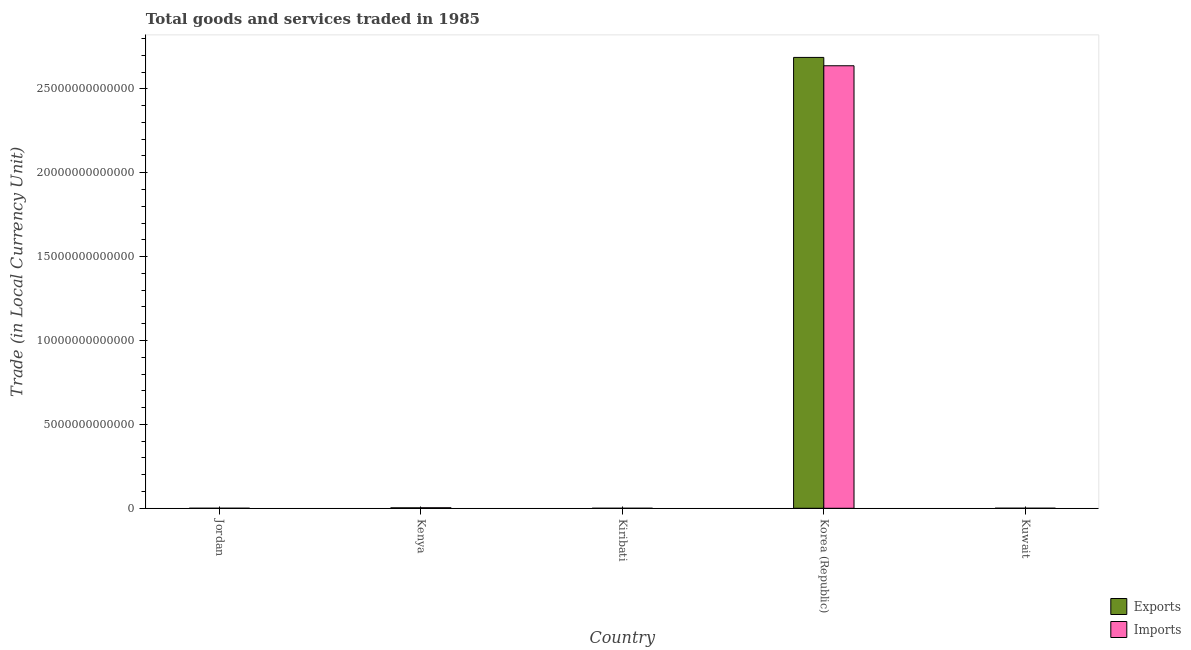How many different coloured bars are there?
Make the answer very short. 2. Are the number of bars per tick equal to the number of legend labels?
Your answer should be compact. Yes. Are the number of bars on each tick of the X-axis equal?
Give a very brief answer. Yes. How many bars are there on the 2nd tick from the left?
Your answer should be compact. 2. What is the label of the 4th group of bars from the left?
Make the answer very short. Korea (Republic). In how many cases, is the number of bars for a given country not equal to the number of legend labels?
Your answer should be compact. 0. What is the export of goods and services in Kenya?
Offer a very short reply. 2.55e+1. Across all countries, what is the maximum export of goods and services?
Ensure brevity in your answer.  2.69e+13. Across all countries, what is the minimum export of goods and services?
Your answer should be very brief. 6.44e+06. In which country was the imports of goods and services maximum?
Make the answer very short. Korea (Republic). In which country was the imports of goods and services minimum?
Your answer should be very brief. Kiribati. What is the total export of goods and services in the graph?
Make the answer very short. 2.69e+13. What is the difference between the imports of goods and services in Jordan and that in Kiribati?
Provide a succinct answer. 1.46e+09. What is the difference between the imports of goods and services in Kenya and the export of goods and services in Korea (Republic)?
Your response must be concise. -2.68e+13. What is the average export of goods and services per country?
Offer a terse response. 5.38e+12. What is the difference between the imports of goods and services and export of goods and services in Kuwait?
Your answer should be very brief. -7.05e+08. What is the ratio of the export of goods and services in Jordan to that in Kenya?
Offer a terse response. 0.03. Is the export of goods and services in Kenya less than that in Korea (Republic)?
Your answer should be very brief. Yes. Is the difference between the export of goods and services in Kenya and Korea (Republic) greater than the difference between the imports of goods and services in Kenya and Korea (Republic)?
Offer a very short reply. No. What is the difference between the highest and the second highest export of goods and services?
Offer a very short reply. 2.69e+13. What is the difference between the highest and the lowest export of goods and services?
Your answer should be very brief. 2.69e+13. Is the sum of the imports of goods and services in Jordan and Kiribati greater than the maximum export of goods and services across all countries?
Keep it short and to the point. No. What does the 2nd bar from the left in Korea (Republic) represents?
Offer a very short reply. Imports. What does the 1st bar from the right in Kuwait represents?
Your answer should be very brief. Imports. How many bars are there?
Give a very brief answer. 10. Are all the bars in the graph horizontal?
Keep it short and to the point. No. What is the difference between two consecutive major ticks on the Y-axis?
Your response must be concise. 5.00e+12. Are the values on the major ticks of Y-axis written in scientific E-notation?
Give a very brief answer. No. How are the legend labels stacked?
Provide a succinct answer. Vertical. What is the title of the graph?
Ensure brevity in your answer.  Total goods and services traded in 1985. What is the label or title of the Y-axis?
Keep it short and to the point. Trade (in Local Currency Unit). What is the Trade (in Local Currency Unit) in Exports in Jordan?
Make the answer very short. 7.82e+08. What is the Trade (in Local Currency Unit) of Imports in Jordan?
Provide a short and direct response. 1.50e+09. What is the Trade (in Local Currency Unit) of Exports in Kenya?
Make the answer very short. 2.55e+1. What is the Trade (in Local Currency Unit) of Imports in Kenya?
Your response must be concise. 3.04e+1. What is the Trade (in Local Currency Unit) of Exports in Kiribati?
Your response must be concise. 6.44e+06. What is the Trade (in Local Currency Unit) in Imports in Kiribati?
Offer a terse response. 3.84e+07. What is the Trade (in Local Currency Unit) in Exports in Korea (Republic)?
Make the answer very short. 2.69e+13. What is the Trade (in Local Currency Unit) of Imports in Korea (Republic)?
Give a very brief answer. 2.64e+13. What is the Trade (in Local Currency Unit) of Exports in Kuwait?
Your answer should be very brief. 3.46e+09. What is the Trade (in Local Currency Unit) of Imports in Kuwait?
Your response must be concise. 2.76e+09. Across all countries, what is the maximum Trade (in Local Currency Unit) of Exports?
Your response must be concise. 2.69e+13. Across all countries, what is the maximum Trade (in Local Currency Unit) of Imports?
Your response must be concise. 2.64e+13. Across all countries, what is the minimum Trade (in Local Currency Unit) of Exports?
Keep it short and to the point. 6.44e+06. Across all countries, what is the minimum Trade (in Local Currency Unit) of Imports?
Give a very brief answer. 3.84e+07. What is the total Trade (in Local Currency Unit) in Exports in the graph?
Give a very brief answer. 2.69e+13. What is the total Trade (in Local Currency Unit) in Imports in the graph?
Your answer should be very brief. 2.64e+13. What is the difference between the Trade (in Local Currency Unit) of Exports in Jordan and that in Kenya?
Make the answer very short. -2.47e+1. What is the difference between the Trade (in Local Currency Unit) in Imports in Jordan and that in Kenya?
Provide a succinct answer. -2.89e+1. What is the difference between the Trade (in Local Currency Unit) in Exports in Jordan and that in Kiribati?
Ensure brevity in your answer.  7.75e+08. What is the difference between the Trade (in Local Currency Unit) of Imports in Jordan and that in Kiribati?
Your answer should be very brief. 1.46e+09. What is the difference between the Trade (in Local Currency Unit) in Exports in Jordan and that in Korea (Republic)?
Keep it short and to the point. -2.69e+13. What is the difference between the Trade (in Local Currency Unit) in Imports in Jordan and that in Korea (Republic)?
Provide a succinct answer. -2.64e+13. What is the difference between the Trade (in Local Currency Unit) in Exports in Jordan and that in Kuwait?
Your answer should be compact. -2.68e+09. What is the difference between the Trade (in Local Currency Unit) in Imports in Jordan and that in Kuwait?
Provide a succinct answer. -1.25e+09. What is the difference between the Trade (in Local Currency Unit) in Exports in Kenya and that in Kiribati?
Provide a short and direct response. 2.55e+1. What is the difference between the Trade (in Local Currency Unit) in Imports in Kenya and that in Kiribati?
Offer a very short reply. 3.04e+1. What is the difference between the Trade (in Local Currency Unit) in Exports in Kenya and that in Korea (Republic)?
Keep it short and to the point. -2.69e+13. What is the difference between the Trade (in Local Currency Unit) of Imports in Kenya and that in Korea (Republic)?
Keep it short and to the point. -2.63e+13. What is the difference between the Trade (in Local Currency Unit) of Exports in Kenya and that in Kuwait?
Give a very brief answer. 2.20e+1. What is the difference between the Trade (in Local Currency Unit) of Imports in Kenya and that in Kuwait?
Provide a succinct answer. 2.76e+1. What is the difference between the Trade (in Local Currency Unit) in Exports in Kiribati and that in Korea (Republic)?
Ensure brevity in your answer.  -2.69e+13. What is the difference between the Trade (in Local Currency Unit) of Imports in Kiribati and that in Korea (Republic)?
Offer a very short reply. -2.64e+13. What is the difference between the Trade (in Local Currency Unit) of Exports in Kiribati and that in Kuwait?
Ensure brevity in your answer.  -3.46e+09. What is the difference between the Trade (in Local Currency Unit) of Imports in Kiribati and that in Kuwait?
Keep it short and to the point. -2.72e+09. What is the difference between the Trade (in Local Currency Unit) in Exports in Korea (Republic) and that in Kuwait?
Your answer should be compact. 2.69e+13. What is the difference between the Trade (in Local Currency Unit) in Imports in Korea (Republic) and that in Kuwait?
Make the answer very short. 2.64e+13. What is the difference between the Trade (in Local Currency Unit) in Exports in Jordan and the Trade (in Local Currency Unit) in Imports in Kenya?
Provide a succinct answer. -2.96e+1. What is the difference between the Trade (in Local Currency Unit) in Exports in Jordan and the Trade (in Local Currency Unit) in Imports in Kiribati?
Make the answer very short. 7.43e+08. What is the difference between the Trade (in Local Currency Unit) of Exports in Jordan and the Trade (in Local Currency Unit) of Imports in Korea (Republic)?
Give a very brief answer. -2.64e+13. What is the difference between the Trade (in Local Currency Unit) of Exports in Jordan and the Trade (in Local Currency Unit) of Imports in Kuwait?
Give a very brief answer. -1.98e+09. What is the difference between the Trade (in Local Currency Unit) of Exports in Kenya and the Trade (in Local Currency Unit) of Imports in Kiribati?
Give a very brief answer. 2.55e+1. What is the difference between the Trade (in Local Currency Unit) in Exports in Kenya and the Trade (in Local Currency Unit) in Imports in Korea (Republic)?
Provide a short and direct response. -2.64e+13. What is the difference between the Trade (in Local Currency Unit) in Exports in Kenya and the Trade (in Local Currency Unit) in Imports in Kuwait?
Make the answer very short. 2.27e+1. What is the difference between the Trade (in Local Currency Unit) of Exports in Kiribati and the Trade (in Local Currency Unit) of Imports in Korea (Republic)?
Your response must be concise. -2.64e+13. What is the difference between the Trade (in Local Currency Unit) in Exports in Kiribati and the Trade (in Local Currency Unit) in Imports in Kuwait?
Your response must be concise. -2.75e+09. What is the difference between the Trade (in Local Currency Unit) in Exports in Korea (Republic) and the Trade (in Local Currency Unit) in Imports in Kuwait?
Your answer should be very brief. 2.69e+13. What is the average Trade (in Local Currency Unit) of Exports per country?
Keep it short and to the point. 5.38e+12. What is the average Trade (in Local Currency Unit) in Imports per country?
Give a very brief answer. 5.28e+12. What is the difference between the Trade (in Local Currency Unit) of Exports and Trade (in Local Currency Unit) of Imports in Jordan?
Keep it short and to the point. -7.21e+08. What is the difference between the Trade (in Local Currency Unit) of Exports and Trade (in Local Currency Unit) of Imports in Kenya?
Provide a short and direct response. -4.89e+09. What is the difference between the Trade (in Local Currency Unit) in Exports and Trade (in Local Currency Unit) in Imports in Kiribati?
Provide a succinct answer. -3.20e+07. What is the difference between the Trade (in Local Currency Unit) in Exports and Trade (in Local Currency Unit) in Imports in Korea (Republic)?
Provide a succinct answer. 4.97e+11. What is the difference between the Trade (in Local Currency Unit) of Exports and Trade (in Local Currency Unit) of Imports in Kuwait?
Offer a terse response. 7.05e+08. What is the ratio of the Trade (in Local Currency Unit) in Exports in Jordan to that in Kenya?
Make the answer very short. 0.03. What is the ratio of the Trade (in Local Currency Unit) in Imports in Jordan to that in Kenya?
Keep it short and to the point. 0.05. What is the ratio of the Trade (in Local Currency Unit) of Exports in Jordan to that in Kiribati?
Offer a very short reply. 121.45. What is the ratio of the Trade (in Local Currency Unit) of Imports in Jordan to that in Kiribati?
Ensure brevity in your answer.  39.14. What is the ratio of the Trade (in Local Currency Unit) of Exports in Jordan to that in Korea (Republic)?
Your response must be concise. 0. What is the ratio of the Trade (in Local Currency Unit) of Exports in Jordan to that in Kuwait?
Ensure brevity in your answer.  0.23. What is the ratio of the Trade (in Local Currency Unit) in Imports in Jordan to that in Kuwait?
Your answer should be very brief. 0.55. What is the ratio of the Trade (in Local Currency Unit) of Exports in Kenya to that in Kiribati?
Offer a very short reply. 3963.37. What is the ratio of the Trade (in Local Currency Unit) in Imports in Kenya to that in Kiribati?
Offer a very short reply. 791.54. What is the ratio of the Trade (in Local Currency Unit) of Exports in Kenya to that in Korea (Republic)?
Your answer should be very brief. 0. What is the ratio of the Trade (in Local Currency Unit) in Imports in Kenya to that in Korea (Republic)?
Provide a short and direct response. 0. What is the ratio of the Trade (in Local Currency Unit) in Exports in Kenya to that in Kuwait?
Provide a succinct answer. 7.37. What is the ratio of the Trade (in Local Currency Unit) of Imports in Kenya to that in Kuwait?
Your answer should be compact. 11.02. What is the ratio of the Trade (in Local Currency Unit) in Imports in Kiribati to that in Korea (Republic)?
Your answer should be very brief. 0. What is the ratio of the Trade (in Local Currency Unit) of Exports in Kiribati to that in Kuwait?
Give a very brief answer. 0. What is the ratio of the Trade (in Local Currency Unit) in Imports in Kiribati to that in Kuwait?
Your response must be concise. 0.01. What is the ratio of the Trade (in Local Currency Unit) of Exports in Korea (Republic) to that in Kuwait?
Offer a terse response. 7763.17. What is the ratio of the Trade (in Local Currency Unit) of Imports in Korea (Republic) to that in Kuwait?
Your answer should be compact. 9568.01. What is the difference between the highest and the second highest Trade (in Local Currency Unit) in Exports?
Ensure brevity in your answer.  2.69e+13. What is the difference between the highest and the second highest Trade (in Local Currency Unit) of Imports?
Keep it short and to the point. 2.63e+13. What is the difference between the highest and the lowest Trade (in Local Currency Unit) of Exports?
Provide a succinct answer. 2.69e+13. What is the difference between the highest and the lowest Trade (in Local Currency Unit) in Imports?
Keep it short and to the point. 2.64e+13. 